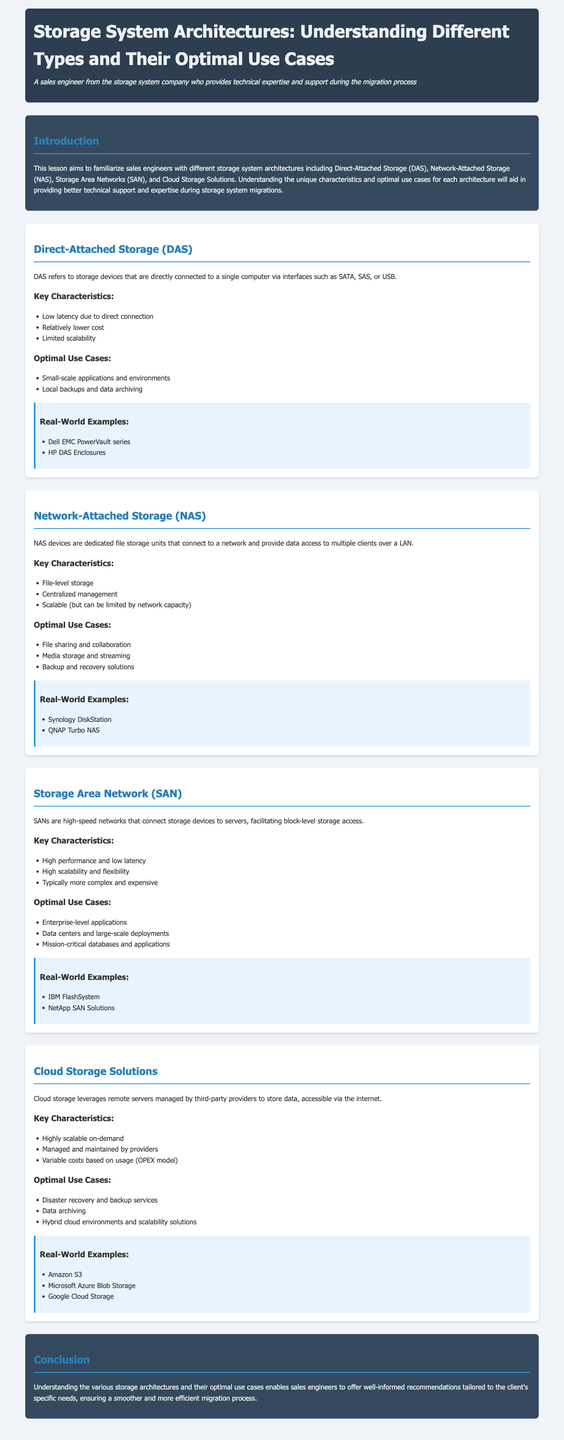What is the primary focus of this lesson? The lesson aims to familiarize sales engineers with different storage system architectures.
Answer: Different storage system architectures What type of storage does DAS refer to? DAS refers to storage devices that are directly connected to a single computer.
Answer: Direct-Attached Storage What is one key characteristic of NAS? NAS devices are dedicated file storage units that connect to a network.
Answer: Centralized management Which storage architecture is known for high performance and low latency? SANs offer high-speed connections and facilitate block-level storage access.
Answer: Storage Area Network What is a common use case for Cloud Storage Solutions? One optimal use case is disaster recovery and backup services.
Answer: Disaster recovery and backup services Name a real-world example of SAN. The document lists IBM FlashSystem as a real-world example.
Answer: IBM FlashSystem How do the costs of Cloud Storage Solutions vary? The costs are variable based on usage, following an OPEX model.
Answer: Based on usage What is a limitation of DAS? DAS has limited scalability since it connects to a single computer.
Answer: Limited scalability Name one real-world example of NAS. The lesson mentions Synology DiskStation as an example.
Answer: Synology DiskStation 